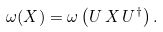<formula> <loc_0><loc_0><loc_500><loc_500>\omega ( X ) = \omega \left ( U \, X \, U ^ { \dagger } \right ) .</formula> 